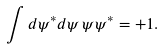<formula> <loc_0><loc_0><loc_500><loc_500>\int d \psi ^ { * } d \psi \, \psi \psi ^ { * } = + 1 .</formula> 